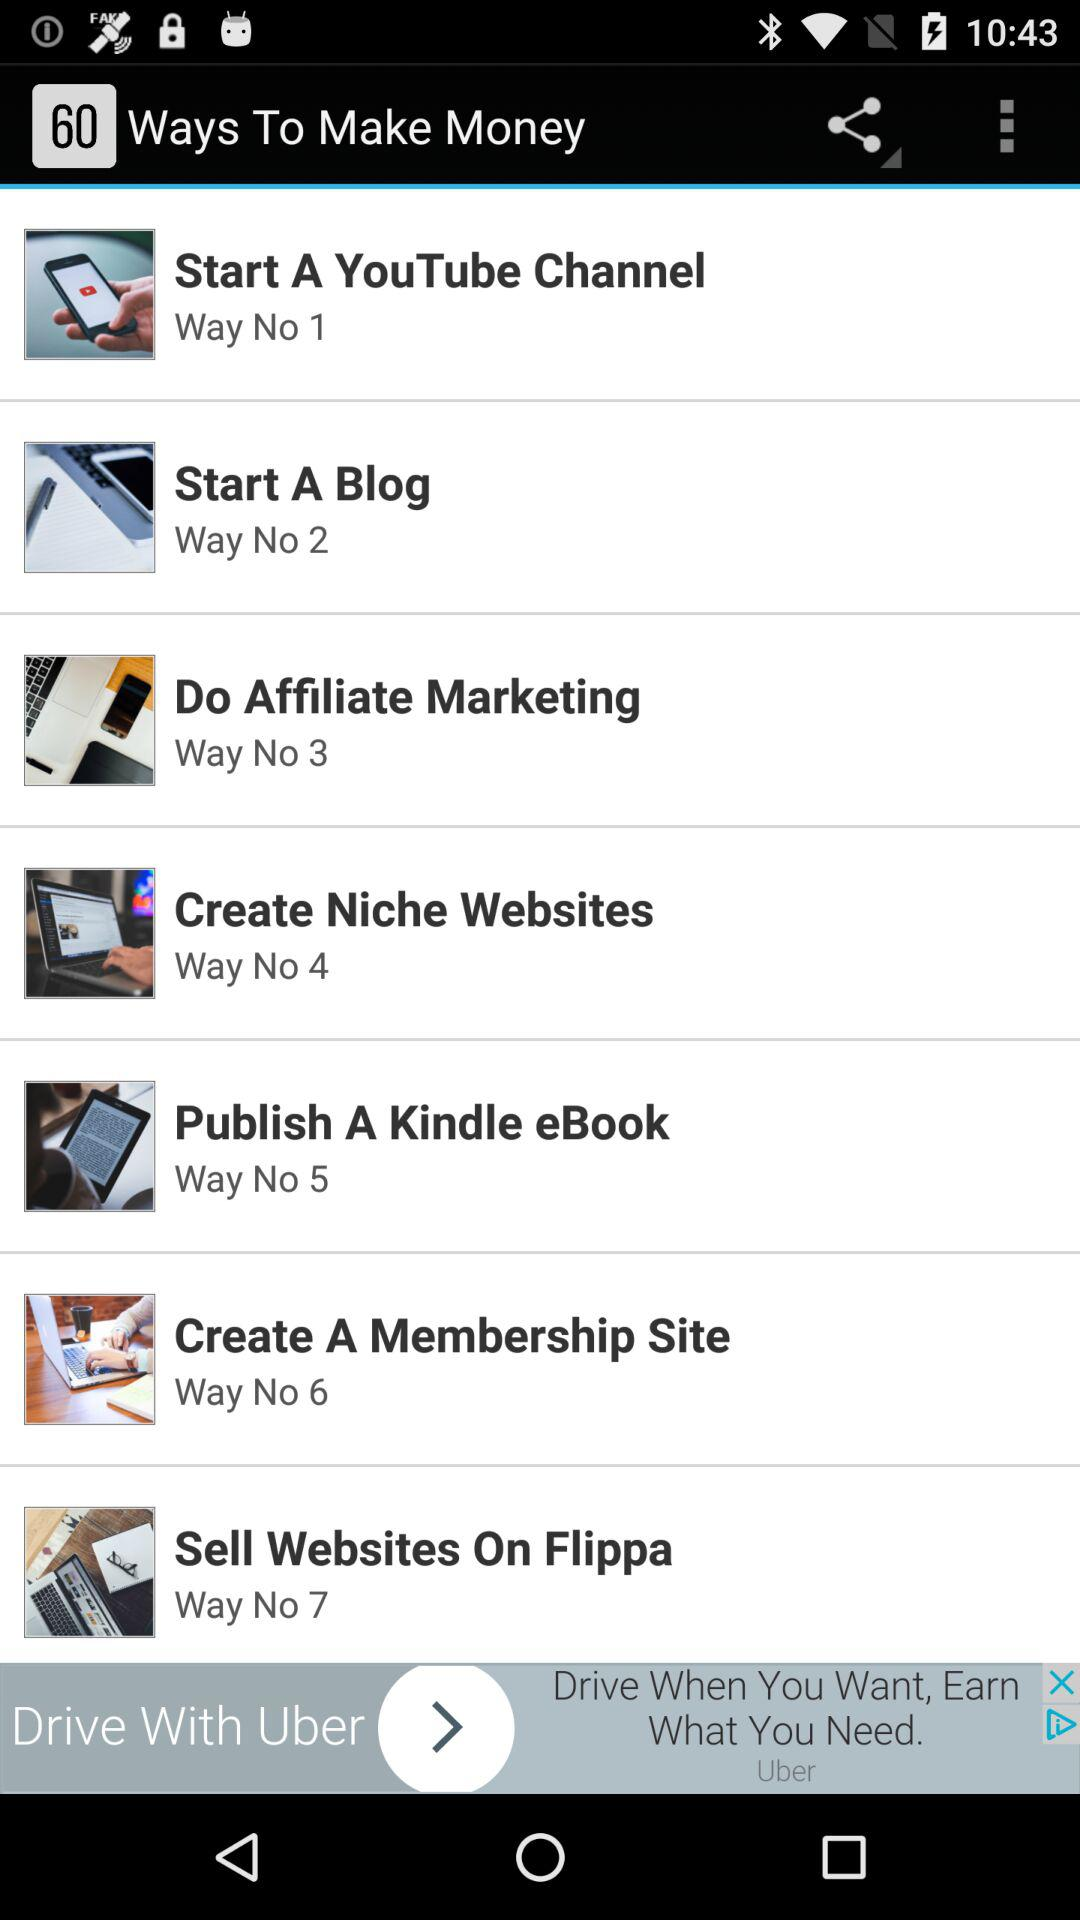What is the way number of "Start A Blog"? The way number of "Start A Blog" is 2. 